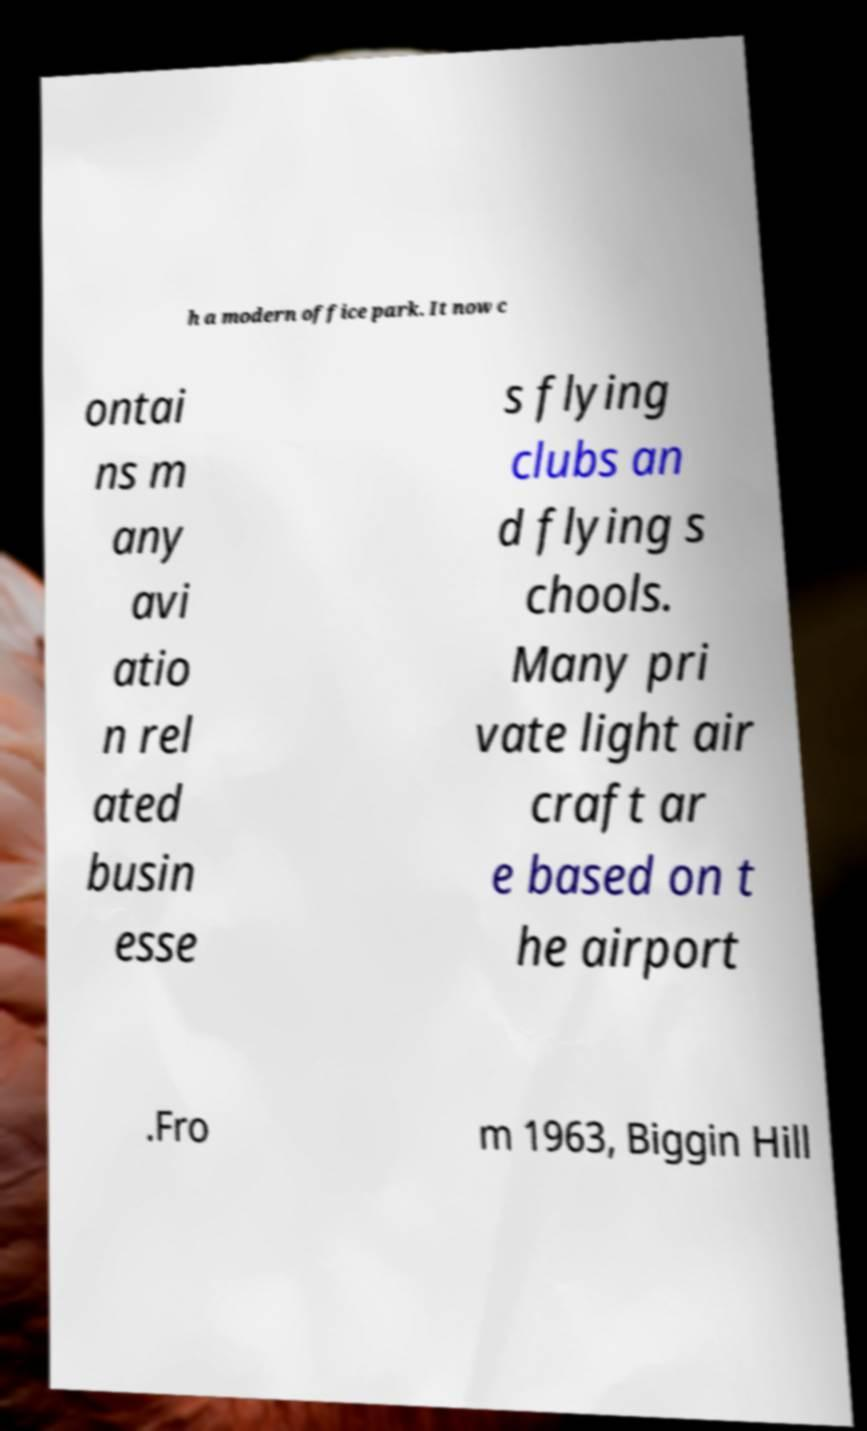Could you extract and type out the text from this image? h a modern office park. It now c ontai ns m any avi atio n rel ated busin esse s flying clubs an d flying s chools. Many pri vate light air craft ar e based on t he airport .Fro m 1963, Biggin Hill 